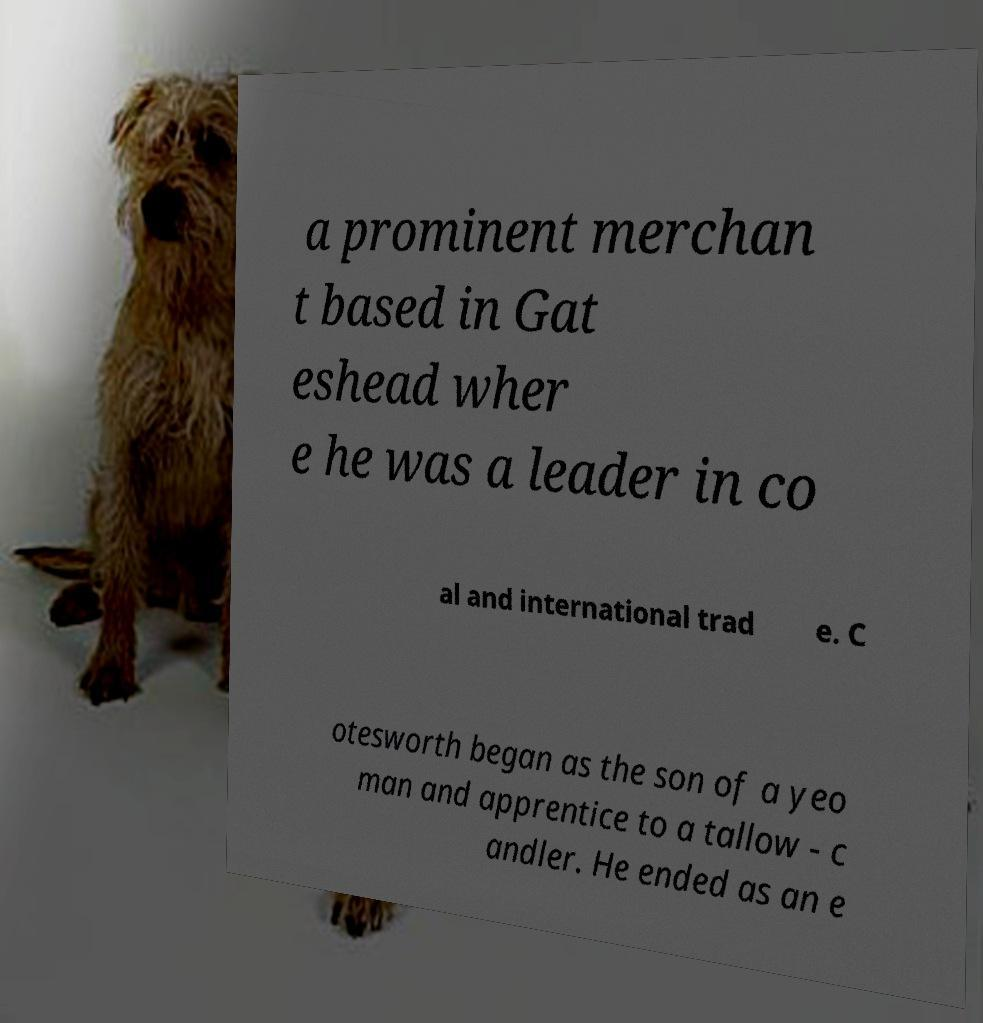Could you extract and type out the text from this image? a prominent merchan t based in Gat eshead wher e he was a leader in co al and international trad e. C otesworth began as the son of a yeo man and apprentice to a tallow - c andler. He ended as an e 